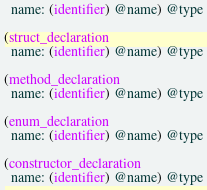<code> <loc_0><loc_0><loc_500><loc_500><_Scheme_>  name: (identifier) @name) @type

(struct_declaration
  name: (identifier) @name) @type

(method_declaration
  name: (identifier) @name) @type

(enum_declaration
  name: (identifier) @name) @type

(constructor_declaration
  name: (identifier) @name) @type
</code> 